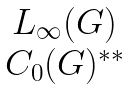Convert formula to latex. <formula><loc_0><loc_0><loc_500><loc_500>\begin{matrix} L _ { \infty } ( G ) \\ C _ { 0 } ( G ) ^ { * * } \end{matrix}</formula> 